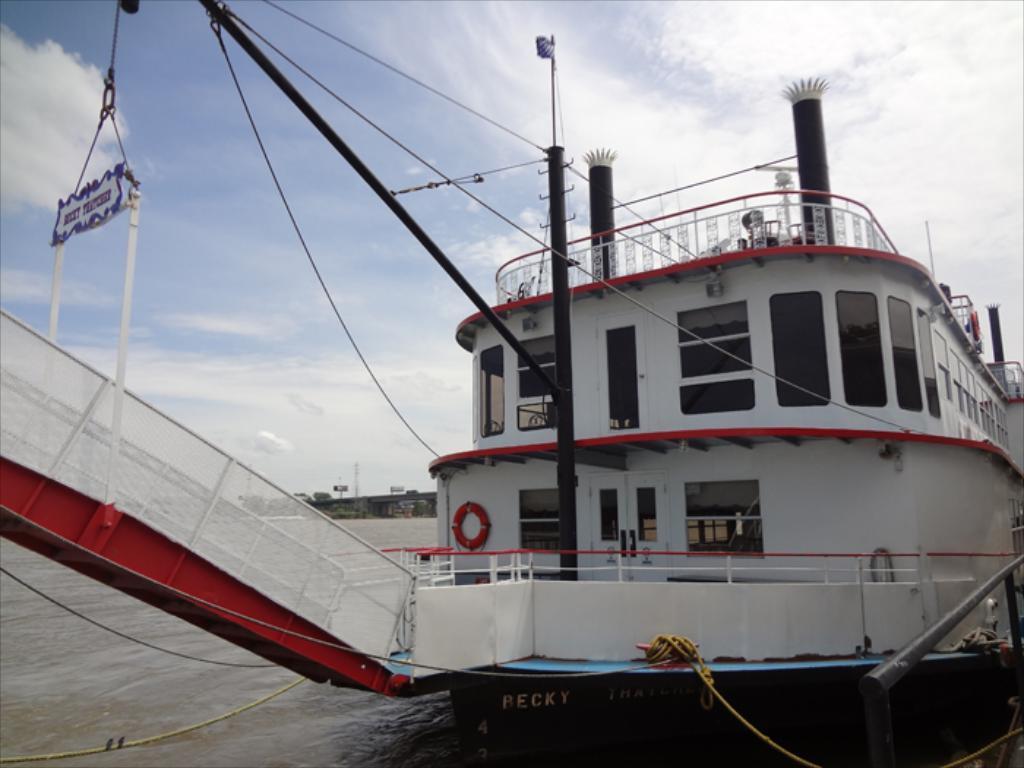Can you describe this image briefly? In this image I can see the ship on the water. The ship is in red and white color. And I can see some windows to it. There are also few ropes to the ship. In the back I can see the clouds and the blue sky. 